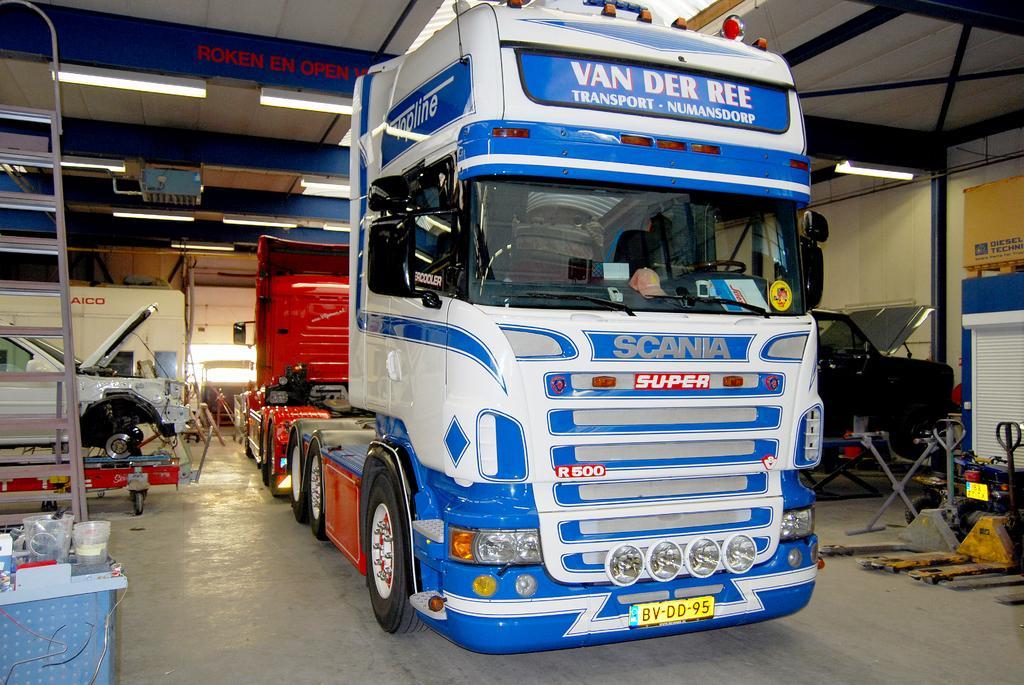Could you give a brief overview of what you see in this image? In the image there is a truck and other vehicles and around the vehicles there are many other objects and there are lights fit to the roof. 